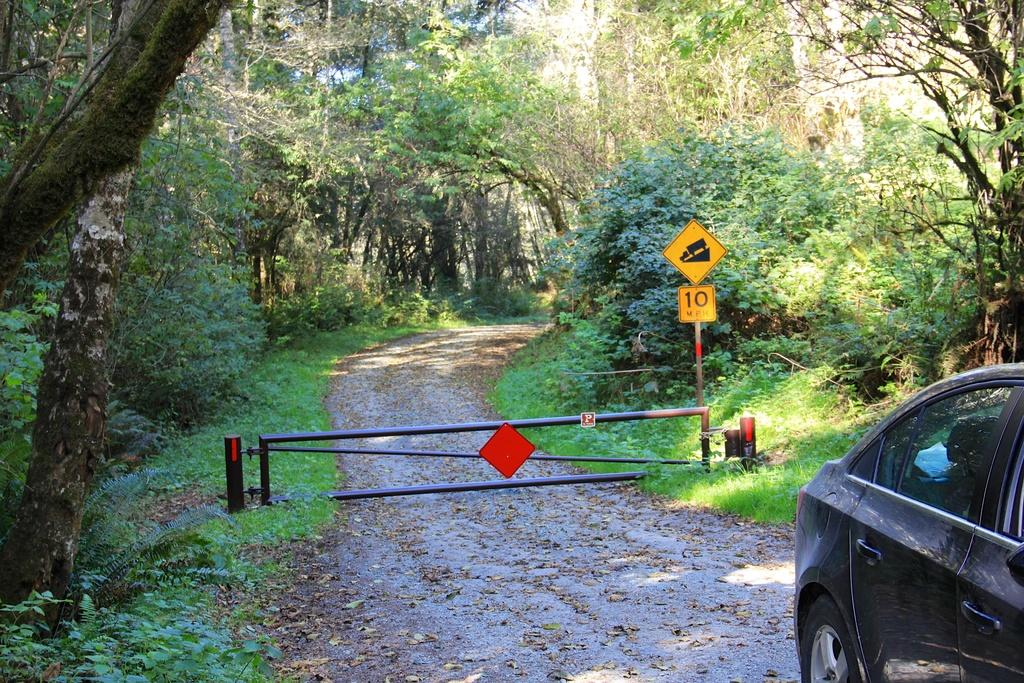What is on the path in the image? There is a vehicle on the path in the image. What structure can be seen in the image? There is a gate in the image. What are the sign boards used for in the image? The sign boards provide information or directions in the image. What type of vegetation is present on both sides of the image? There are trees on the left side and right side of the image. Where is the sofa located in the image? There is no sofa present in the image. What type of pancake is being served at the gate in the image? There is no pancake present in the image, and the gate is not serving any food. 